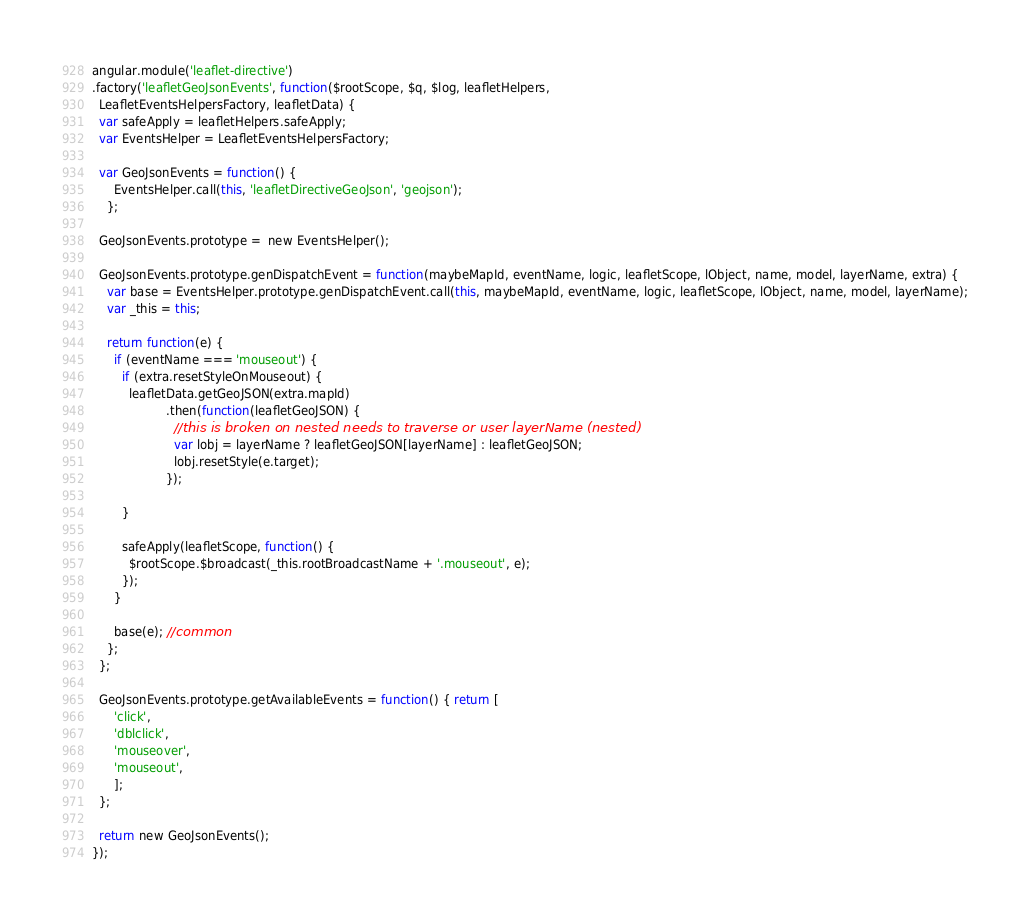<code> <loc_0><loc_0><loc_500><loc_500><_JavaScript_>angular.module('leaflet-directive')
.factory('leafletGeoJsonEvents', function($rootScope, $q, $log, leafletHelpers,
  LeafletEventsHelpersFactory, leafletData) {
  var safeApply = leafletHelpers.safeApply;
  var EventsHelper = LeafletEventsHelpersFactory;

  var GeoJsonEvents = function() {
      EventsHelper.call(this, 'leafletDirectiveGeoJson', 'geojson');
    };

  GeoJsonEvents.prototype =  new EventsHelper();

  GeoJsonEvents.prototype.genDispatchEvent = function(maybeMapId, eventName, logic, leafletScope, lObject, name, model, layerName, extra) {
    var base = EventsHelper.prototype.genDispatchEvent.call(this, maybeMapId, eventName, logic, leafletScope, lObject, name, model, layerName);
    var _this = this;

    return function(e) {
      if (eventName === 'mouseout') {
        if (extra.resetStyleOnMouseout) {
          leafletData.getGeoJSON(extra.mapId)
                    .then(function(leafletGeoJSON) {
                      //this is broken on nested needs to traverse or user layerName (nested)
                      var lobj = layerName ? leafletGeoJSON[layerName] : leafletGeoJSON;
                      lobj.resetStyle(e.target);
                    });

        }

        safeApply(leafletScope, function() {
          $rootScope.$broadcast(_this.rootBroadcastName + '.mouseout', e);
        });
      }

      base(e); //common
    };
  };

  GeoJsonEvents.prototype.getAvailableEvents = function() { return [
      'click',
      'dblclick',
      'mouseover',
      'mouseout',
      ];
  };

  return new GeoJsonEvents();
});
</code> 